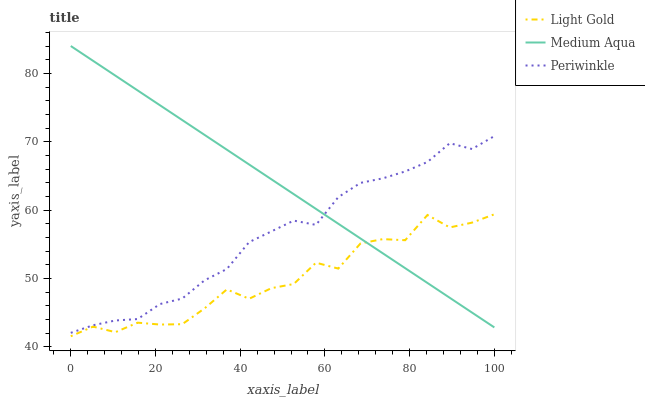Does Light Gold have the minimum area under the curve?
Answer yes or no. Yes. Does Medium Aqua have the maximum area under the curve?
Answer yes or no. Yes. Does Periwinkle have the minimum area under the curve?
Answer yes or no. No. Does Periwinkle have the maximum area under the curve?
Answer yes or no. No. Is Medium Aqua the smoothest?
Answer yes or no. Yes. Is Light Gold the roughest?
Answer yes or no. Yes. Is Periwinkle the smoothest?
Answer yes or no. No. Is Periwinkle the roughest?
Answer yes or no. No. Does Light Gold have the lowest value?
Answer yes or no. Yes. Does Periwinkle have the lowest value?
Answer yes or no. No. Does Medium Aqua have the highest value?
Answer yes or no. Yes. Does Periwinkle have the highest value?
Answer yes or no. No. Is Light Gold less than Periwinkle?
Answer yes or no. Yes. Is Periwinkle greater than Light Gold?
Answer yes or no. Yes. Does Medium Aqua intersect Light Gold?
Answer yes or no. Yes. Is Medium Aqua less than Light Gold?
Answer yes or no. No. Is Medium Aqua greater than Light Gold?
Answer yes or no. No. Does Light Gold intersect Periwinkle?
Answer yes or no. No. 